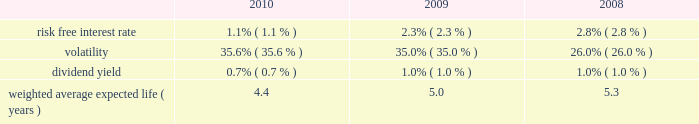The weighted average fair value of options granted during 2010 , 2009 and 2008 was estimated to be $ 7.84 , $ 7.18 and $ 3.84 , respectively , using the black-scholes option pricing model with the assumptions below: .
At december 31 , 2010 and 2009 , the total unrecognized compensation cost related to non-vested stock awards is $ 129.3 million and $ 93.5 million , respectively , which is expected to be recognized in pre-tax income over a weighted average period of 1.7 years as of both year ends .
The company granted a total of 1.5 million restricted stock awards at prices ranging from $ 25.76 to $ 28.15 on various dates in 2010 .
These awards vest annually over three years .
The company also granted 0.9 million performance restricted stock units during 2010 .
These performance restricted stock units have been granted at the maximum achievable level and the number of shares that can vest is based on specific revenue and ebitda goals for periods from 2010 through 2012 .
During 2009 , we granted 0.5 million shares of restricted stock at a price of $ 22.55 that vest annually over 3 years .
On october 1 , 2009 , the company granted 0.4 million restricted stock units at a price of $ 24.85 per share that vested over six months .
On march 20 , 2008 , we granted 0.4 million shares of restricted stock at a price of $ 38.75 that were to vest quarterly over 2 years .
On july 2 , 2008 , 0.2 million of these shares were canceled and assumed by lps .
The remaining unvested restricted shares were converted by the conversion factor of 1.7952 .
These awards vested as of october 1 , 2009 , under the change in control provisions due to the metavante acquisition .
On october 27 , 2008 , we granted 0.8 million shares of restricted stock at a price of $ 14.35 that vest annually over 3 years .
As of december 31 , 2010 and 2009 , we have approximately 2.2 million and 1.4 million unvested restricted shares remaining .
As of december 31 , 2010 we also have 0.6 million of restricted stock units that have not vested .
Share repurchase plans on october 25 , 2006 , our board of directors approved a plan authorizing repurchases of up to $ 200.0 million worth of our common stock ( the 201cold plan 201d ) .
On april 17 , 2008 , our board of directors approved a plan authorizing repurchases of up to an additional $ 250.0 million worth of our common stock ( the 201cnew plan 201d ) .
Under the new plan we repurchased 5.8 million shares of our stock for $ 226.2 million , at an average price of $ 38.97 for the year ended december 31 , 2008 .
During the year ended december 31 , 2008 , we also repurchased an additional 0.2 million shares of our stock for $ 10.0 million at an average price of $ 40.56 under the old plan .
During 2007 , the company repurchased 1.6 million shares at an average price of $ 49.15 under the old plan .
On february 4 , 2010 our board of directors approved a plan authorizing repurchases of up to 15.0 million shares of our common stock in the open market , at prevailing market prices or in privately negotiated transactions , through january 31 , 2013 .
We repurchased 1.4 million shares of our common stock for $ 32.2 million , at an average price of $ 22.97 through march 31 , 2010 .
No additional shares were repurchased under this plan during the year ended december 31 , 2010 .
Approximately 13.6 million shares of our common stock remain available to repurchase under this plan as of december 31 , 2010 .
On may 25 , 2010 , our board of directors authorized a leveraged recapitalization plan to repurchase up to $ 2.5 billion of our common stock at a price range of $ 29.00 2014 $ 31.00 per share of common stock through a modified 201cdutch auction 201d tender offer ( the 201ctender offer 201d ) .
The tender offer commenced on july 6 , 2010 and expired on august 3 , 2010 .
The tender offer was oversubscribed at $ 29.00 , resulting in the purchase of 86.2 million shares , including 6.4 million shares underlying previously unexercised stock options .
The repurchased shares were added to treasury stock .
Fidelity national information services , inc .
And subsidiaries notes to consolidated financial statements 2014 ( continued ) %%transmsg*** transmitting job : g26369 pcn : 087000000 ***%%pcmsg|87 |00008|yes|no|03/28/2011 17:32|0|0|page is valid , no graphics -- color : n| .
Assuming a stock price of $ 22.97 in 2010 , what would be the dividend per share? 
Computations: (22.97 * 0.7%)
Answer: 0.16079. 